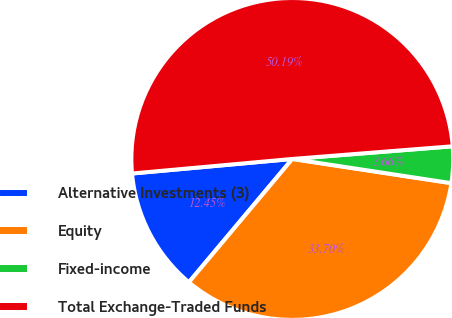<chart> <loc_0><loc_0><loc_500><loc_500><pie_chart><fcel>Alternative Investments (3)<fcel>Equity<fcel>Fixed-income<fcel>Total Exchange-Traded Funds<nl><fcel>12.45%<fcel>33.7%<fcel>3.66%<fcel>50.18%<nl></chart> 